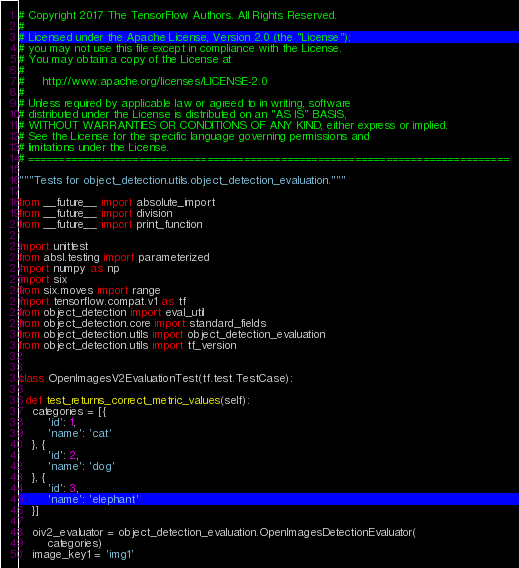Convert code to text. <code><loc_0><loc_0><loc_500><loc_500><_Python_># Copyright 2017 The TensorFlow Authors. All Rights Reserved.
#
# Licensed under the Apache License, Version 2.0 (the "License");
# you may not use this file except in compliance with the License.
# You may obtain a copy of the License at
#
#     http://www.apache.org/licenses/LICENSE-2.0
#
# Unless required by applicable law or agreed to in writing, software
# distributed under the License is distributed on an "AS IS" BASIS,
# WITHOUT WARRANTIES OR CONDITIONS OF ANY KIND, either express or implied.
# See the License for the specific language governing permissions and
# limitations under the License.
# ==============================================================================

"""Tests for object_detection.utils.object_detection_evaluation."""

from __future__ import absolute_import
from __future__ import division
from __future__ import print_function

import unittest
from absl.testing import parameterized
import numpy as np
import six
from six.moves import range
import tensorflow.compat.v1 as tf
from object_detection import eval_util
from object_detection.core import standard_fields
from object_detection.utils import object_detection_evaluation
from object_detection.utils import tf_version


class OpenImagesV2EvaluationTest(tf.test.TestCase):

  def test_returns_correct_metric_values(self):
    categories = [{
        'id': 1,
        'name': 'cat'
    }, {
        'id': 2,
        'name': 'dog'
    }, {
        'id': 3,
        'name': 'elephant'
    }]

    oiv2_evaluator = object_detection_evaluation.OpenImagesDetectionEvaluator(
        categories)
    image_key1 = 'img1'</code> 